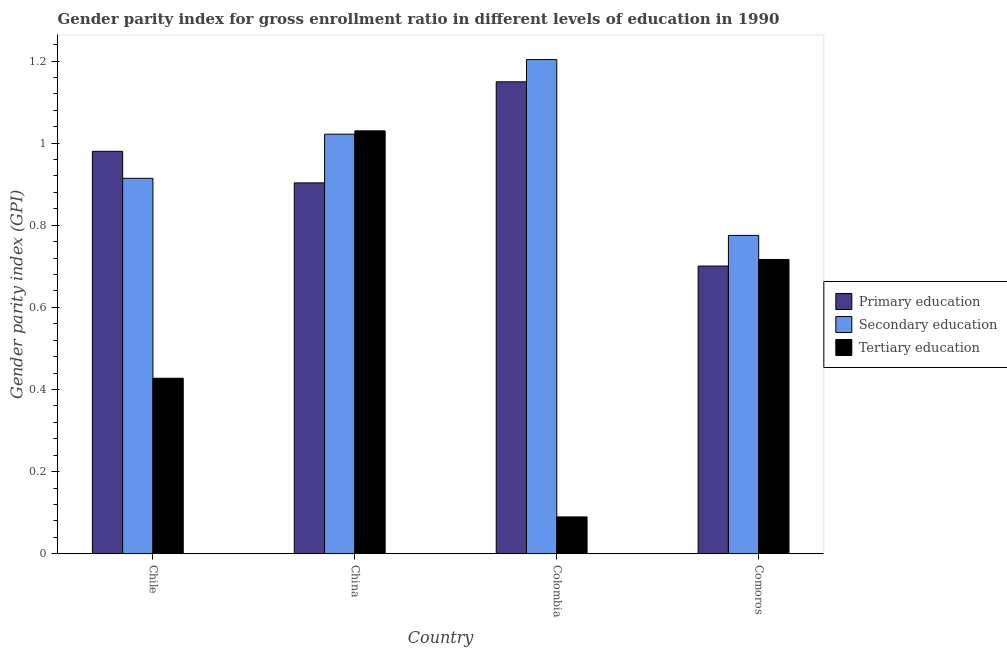How many groups of bars are there?
Make the answer very short. 4. How many bars are there on the 2nd tick from the left?
Give a very brief answer. 3. What is the label of the 2nd group of bars from the left?
Make the answer very short. China. In how many cases, is the number of bars for a given country not equal to the number of legend labels?
Offer a very short reply. 0. What is the gender parity index in tertiary education in Colombia?
Provide a short and direct response. 0.09. Across all countries, what is the maximum gender parity index in tertiary education?
Your response must be concise. 1.03. Across all countries, what is the minimum gender parity index in primary education?
Give a very brief answer. 0.7. In which country was the gender parity index in tertiary education maximum?
Ensure brevity in your answer.  China. In which country was the gender parity index in tertiary education minimum?
Give a very brief answer. Colombia. What is the total gender parity index in primary education in the graph?
Provide a short and direct response. 3.73. What is the difference between the gender parity index in tertiary education in Colombia and that in Comoros?
Give a very brief answer. -0.63. What is the difference between the gender parity index in primary education in China and the gender parity index in tertiary education in Colombia?
Provide a short and direct response. 0.81. What is the average gender parity index in tertiary education per country?
Keep it short and to the point. 0.57. What is the difference between the gender parity index in tertiary education and gender parity index in secondary education in Comoros?
Provide a short and direct response. -0.06. In how many countries, is the gender parity index in primary education greater than 0.7200000000000001 ?
Your answer should be compact. 3. What is the ratio of the gender parity index in tertiary education in Colombia to that in Comoros?
Provide a succinct answer. 0.13. Is the gender parity index in tertiary education in Chile less than that in China?
Keep it short and to the point. Yes. What is the difference between the highest and the second highest gender parity index in tertiary education?
Offer a very short reply. 0.31. What is the difference between the highest and the lowest gender parity index in secondary education?
Your answer should be compact. 0.43. What does the 2nd bar from the left in Colombia represents?
Your answer should be compact. Secondary education. What does the 3rd bar from the right in Colombia represents?
Offer a very short reply. Primary education. How many bars are there?
Provide a short and direct response. 12. Are all the bars in the graph horizontal?
Your answer should be compact. No. Does the graph contain any zero values?
Offer a terse response. No. How many legend labels are there?
Ensure brevity in your answer.  3. How are the legend labels stacked?
Keep it short and to the point. Vertical. What is the title of the graph?
Your answer should be very brief. Gender parity index for gross enrollment ratio in different levels of education in 1990. What is the label or title of the X-axis?
Offer a terse response. Country. What is the label or title of the Y-axis?
Keep it short and to the point. Gender parity index (GPI). What is the Gender parity index (GPI) in Primary education in Chile?
Your response must be concise. 0.98. What is the Gender parity index (GPI) in Secondary education in Chile?
Provide a short and direct response. 0.91. What is the Gender parity index (GPI) in Tertiary education in Chile?
Your response must be concise. 0.43. What is the Gender parity index (GPI) in Primary education in China?
Offer a very short reply. 0.9. What is the Gender parity index (GPI) in Secondary education in China?
Ensure brevity in your answer.  1.02. What is the Gender parity index (GPI) in Tertiary education in China?
Offer a terse response. 1.03. What is the Gender parity index (GPI) of Primary education in Colombia?
Your answer should be compact. 1.15. What is the Gender parity index (GPI) of Secondary education in Colombia?
Provide a succinct answer. 1.2. What is the Gender parity index (GPI) of Tertiary education in Colombia?
Offer a very short reply. 0.09. What is the Gender parity index (GPI) of Primary education in Comoros?
Your answer should be very brief. 0.7. What is the Gender parity index (GPI) in Secondary education in Comoros?
Make the answer very short. 0.78. What is the Gender parity index (GPI) of Tertiary education in Comoros?
Your answer should be very brief. 0.72. Across all countries, what is the maximum Gender parity index (GPI) of Primary education?
Your answer should be very brief. 1.15. Across all countries, what is the maximum Gender parity index (GPI) of Secondary education?
Make the answer very short. 1.2. Across all countries, what is the maximum Gender parity index (GPI) of Tertiary education?
Your response must be concise. 1.03. Across all countries, what is the minimum Gender parity index (GPI) of Primary education?
Provide a short and direct response. 0.7. Across all countries, what is the minimum Gender parity index (GPI) in Secondary education?
Ensure brevity in your answer.  0.78. Across all countries, what is the minimum Gender parity index (GPI) in Tertiary education?
Offer a very short reply. 0.09. What is the total Gender parity index (GPI) in Primary education in the graph?
Your answer should be compact. 3.73. What is the total Gender parity index (GPI) of Secondary education in the graph?
Give a very brief answer. 3.91. What is the total Gender parity index (GPI) in Tertiary education in the graph?
Offer a very short reply. 2.26. What is the difference between the Gender parity index (GPI) of Primary education in Chile and that in China?
Make the answer very short. 0.08. What is the difference between the Gender parity index (GPI) of Secondary education in Chile and that in China?
Ensure brevity in your answer.  -0.11. What is the difference between the Gender parity index (GPI) in Tertiary education in Chile and that in China?
Provide a short and direct response. -0.6. What is the difference between the Gender parity index (GPI) in Primary education in Chile and that in Colombia?
Provide a short and direct response. -0.17. What is the difference between the Gender parity index (GPI) of Secondary education in Chile and that in Colombia?
Provide a succinct answer. -0.29. What is the difference between the Gender parity index (GPI) of Tertiary education in Chile and that in Colombia?
Make the answer very short. 0.34. What is the difference between the Gender parity index (GPI) of Primary education in Chile and that in Comoros?
Provide a succinct answer. 0.28. What is the difference between the Gender parity index (GPI) of Secondary education in Chile and that in Comoros?
Your answer should be compact. 0.14. What is the difference between the Gender parity index (GPI) of Tertiary education in Chile and that in Comoros?
Your answer should be very brief. -0.29. What is the difference between the Gender parity index (GPI) in Primary education in China and that in Colombia?
Your response must be concise. -0.25. What is the difference between the Gender parity index (GPI) in Secondary education in China and that in Colombia?
Ensure brevity in your answer.  -0.18. What is the difference between the Gender parity index (GPI) in Tertiary education in China and that in Colombia?
Make the answer very short. 0.94. What is the difference between the Gender parity index (GPI) of Primary education in China and that in Comoros?
Your answer should be compact. 0.2. What is the difference between the Gender parity index (GPI) of Secondary education in China and that in Comoros?
Offer a terse response. 0.25. What is the difference between the Gender parity index (GPI) of Tertiary education in China and that in Comoros?
Your response must be concise. 0.31. What is the difference between the Gender parity index (GPI) in Primary education in Colombia and that in Comoros?
Provide a short and direct response. 0.45. What is the difference between the Gender parity index (GPI) in Secondary education in Colombia and that in Comoros?
Offer a very short reply. 0.43. What is the difference between the Gender parity index (GPI) in Tertiary education in Colombia and that in Comoros?
Make the answer very short. -0.63. What is the difference between the Gender parity index (GPI) in Primary education in Chile and the Gender parity index (GPI) in Secondary education in China?
Your response must be concise. -0.04. What is the difference between the Gender parity index (GPI) of Primary education in Chile and the Gender parity index (GPI) of Tertiary education in China?
Ensure brevity in your answer.  -0.05. What is the difference between the Gender parity index (GPI) of Secondary education in Chile and the Gender parity index (GPI) of Tertiary education in China?
Offer a very short reply. -0.12. What is the difference between the Gender parity index (GPI) in Primary education in Chile and the Gender parity index (GPI) in Secondary education in Colombia?
Give a very brief answer. -0.22. What is the difference between the Gender parity index (GPI) of Primary education in Chile and the Gender parity index (GPI) of Tertiary education in Colombia?
Keep it short and to the point. 0.89. What is the difference between the Gender parity index (GPI) in Secondary education in Chile and the Gender parity index (GPI) in Tertiary education in Colombia?
Your response must be concise. 0.82. What is the difference between the Gender parity index (GPI) of Primary education in Chile and the Gender parity index (GPI) of Secondary education in Comoros?
Your answer should be very brief. 0.2. What is the difference between the Gender parity index (GPI) of Primary education in Chile and the Gender parity index (GPI) of Tertiary education in Comoros?
Your response must be concise. 0.26. What is the difference between the Gender parity index (GPI) in Secondary education in Chile and the Gender parity index (GPI) in Tertiary education in Comoros?
Provide a short and direct response. 0.2. What is the difference between the Gender parity index (GPI) in Primary education in China and the Gender parity index (GPI) in Secondary education in Colombia?
Offer a terse response. -0.3. What is the difference between the Gender parity index (GPI) of Primary education in China and the Gender parity index (GPI) of Tertiary education in Colombia?
Give a very brief answer. 0.81. What is the difference between the Gender parity index (GPI) of Secondary education in China and the Gender parity index (GPI) of Tertiary education in Colombia?
Make the answer very short. 0.93. What is the difference between the Gender parity index (GPI) in Primary education in China and the Gender parity index (GPI) in Secondary education in Comoros?
Provide a succinct answer. 0.13. What is the difference between the Gender parity index (GPI) in Primary education in China and the Gender parity index (GPI) in Tertiary education in Comoros?
Your answer should be very brief. 0.19. What is the difference between the Gender parity index (GPI) of Secondary education in China and the Gender parity index (GPI) of Tertiary education in Comoros?
Offer a terse response. 0.31. What is the difference between the Gender parity index (GPI) of Primary education in Colombia and the Gender parity index (GPI) of Secondary education in Comoros?
Keep it short and to the point. 0.37. What is the difference between the Gender parity index (GPI) of Primary education in Colombia and the Gender parity index (GPI) of Tertiary education in Comoros?
Give a very brief answer. 0.43. What is the difference between the Gender parity index (GPI) in Secondary education in Colombia and the Gender parity index (GPI) in Tertiary education in Comoros?
Give a very brief answer. 0.49. What is the average Gender parity index (GPI) of Secondary education per country?
Provide a short and direct response. 0.98. What is the average Gender parity index (GPI) of Tertiary education per country?
Offer a very short reply. 0.57. What is the difference between the Gender parity index (GPI) of Primary education and Gender parity index (GPI) of Secondary education in Chile?
Offer a terse response. 0.07. What is the difference between the Gender parity index (GPI) in Primary education and Gender parity index (GPI) in Tertiary education in Chile?
Provide a succinct answer. 0.55. What is the difference between the Gender parity index (GPI) of Secondary education and Gender parity index (GPI) of Tertiary education in Chile?
Ensure brevity in your answer.  0.49. What is the difference between the Gender parity index (GPI) of Primary education and Gender parity index (GPI) of Secondary education in China?
Offer a terse response. -0.12. What is the difference between the Gender parity index (GPI) in Primary education and Gender parity index (GPI) in Tertiary education in China?
Provide a succinct answer. -0.13. What is the difference between the Gender parity index (GPI) in Secondary education and Gender parity index (GPI) in Tertiary education in China?
Offer a terse response. -0.01. What is the difference between the Gender parity index (GPI) of Primary education and Gender parity index (GPI) of Secondary education in Colombia?
Offer a very short reply. -0.05. What is the difference between the Gender parity index (GPI) of Primary education and Gender parity index (GPI) of Tertiary education in Colombia?
Your response must be concise. 1.06. What is the difference between the Gender parity index (GPI) of Secondary education and Gender parity index (GPI) of Tertiary education in Colombia?
Offer a terse response. 1.11. What is the difference between the Gender parity index (GPI) of Primary education and Gender parity index (GPI) of Secondary education in Comoros?
Offer a terse response. -0.07. What is the difference between the Gender parity index (GPI) of Primary education and Gender parity index (GPI) of Tertiary education in Comoros?
Your response must be concise. -0.02. What is the difference between the Gender parity index (GPI) of Secondary education and Gender parity index (GPI) of Tertiary education in Comoros?
Provide a short and direct response. 0.06. What is the ratio of the Gender parity index (GPI) in Primary education in Chile to that in China?
Your response must be concise. 1.09. What is the ratio of the Gender parity index (GPI) in Secondary education in Chile to that in China?
Your answer should be compact. 0.89. What is the ratio of the Gender parity index (GPI) in Tertiary education in Chile to that in China?
Give a very brief answer. 0.41. What is the ratio of the Gender parity index (GPI) of Primary education in Chile to that in Colombia?
Your answer should be very brief. 0.85. What is the ratio of the Gender parity index (GPI) in Secondary education in Chile to that in Colombia?
Keep it short and to the point. 0.76. What is the ratio of the Gender parity index (GPI) in Tertiary education in Chile to that in Colombia?
Offer a terse response. 4.77. What is the ratio of the Gender parity index (GPI) of Primary education in Chile to that in Comoros?
Give a very brief answer. 1.4. What is the ratio of the Gender parity index (GPI) of Secondary education in Chile to that in Comoros?
Provide a short and direct response. 1.18. What is the ratio of the Gender parity index (GPI) in Tertiary education in Chile to that in Comoros?
Your answer should be very brief. 0.6. What is the ratio of the Gender parity index (GPI) in Primary education in China to that in Colombia?
Offer a very short reply. 0.79. What is the ratio of the Gender parity index (GPI) in Secondary education in China to that in Colombia?
Provide a short and direct response. 0.85. What is the ratio of the Gender parity index (GPI) in Tertiary education in China to that in Colombia?
Make the answer very short. 11.49. What is the ratio of the Gender parity index (GPI) in Primary education in China to that in Comoros?
Offer a terse response. 1.29. What is the ratio of the Gender parity index (GPI) in Secondary education in China to that in Comoros?
Ensure brevity in your answer.  1.32. What is the ratio of the Gender parity index (GPI) of Tertiary education in China to that in Comoros?
Offer a terse response. 1.44. What is the ratio of the Gender parity index (GPI) in Primary education in Colombia to that in Comoros?
Make the answer very short. 1.64. What is the ratio of the Gender parity index (GPI) in Secondary education in Colombia to that in Comoros?
Ensure brevity in your answer.  1.55. What is the ratio of the Gender parity index (GPI) of Tertiary education in Colombia to that in Comoros?
Make the answer very short. 0.13. What is the difference between the highest and the second highest Gender parity index (GPI) of Primary education?
Provide a short and direct response. 0.17. What is the difference between the highest and the second highest Gender parity index (GPI) of Secondary education?
Ensure brevity in your answer.  0.18. What is the difference between the highest and the second highest Gender parity index (GPI) in Tertiary education?
Provide a short and direct response. 0.31. What is the difference between the highest and the lowest Gender parity index (GPI) of Primary education?
Provide a short and direct response. 0.45. What is the difference between the highest and the lowest Gender parity index (GPI) in Secondary education?
Offer a very short reply. 0.43. What is the difference between the highest and the lowest Gender parity index (GPI) of Tertiary education?
Your answer should be compact. 0.94. 